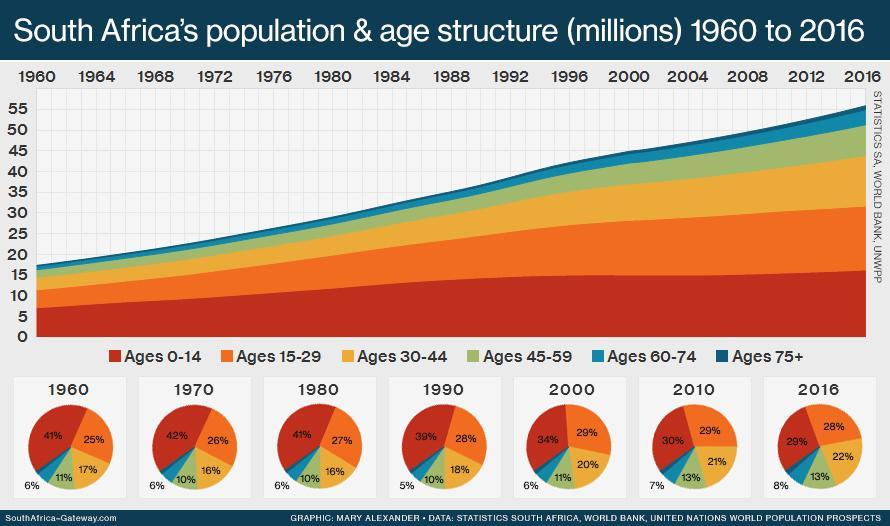Which age group is represented in red colour?
Answer the question with a short phrase. Ages 0-14 In 1970, what percentage of the population belonged to the age group 15-29? 26% In 1990 what percentage of the population belonged to the age group 45-59? 10% In 1980, which age group had the highest population? Ages 0-14 Which age group is represented in yellow colour? Ages 30-44 In 2010 what percentage of the population belonged to the age group 45-59? 13% Over the seven decades, the population % of which age group has shown a continuous decline? Ages 0-14 In 1960, what percentage of the population belonged to the age groups 0-14? 41% The population distribution for how many years is shown here? 7 In which year, was the population in the ages 60-74, the highest? 2016 Into how many age groups is the population classified? 6 